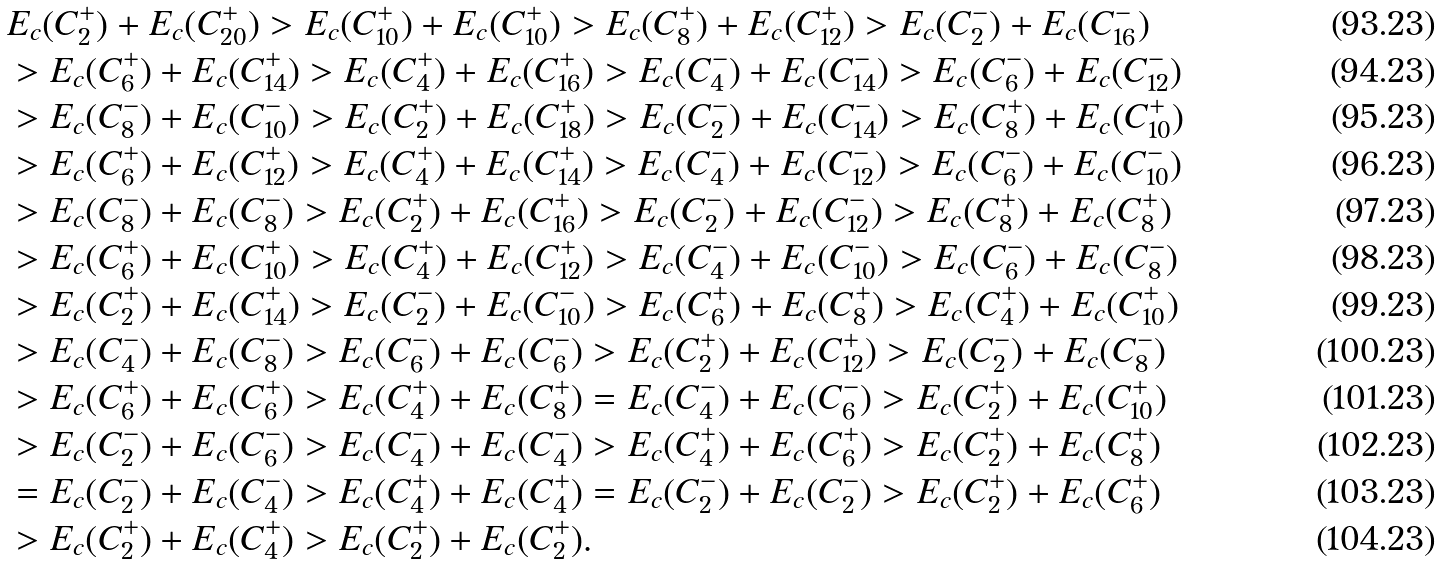Convert formula to latex. <formula><loc_0><loc_0><loc_500><loc_500>& E _ { c } ( C _ { 2 } ^ { + } ) + E _ { c } ( C _ { 2 0 } ^ { + } ) > E _ { c } ( C _ { 1 0 } ^ { + } ) + E _ { c } ( C _ { 1 0 } ^ { + } ) > E _ { c } ( C _ { 8 } ^ { + } ) + E _ { c } ( C _ { 1 2 } ^ { + } ) > E _ { c } ( C _ { 2 } ^ { - } ) + E _ { c } ( C _ { 1 6 } ^ { - } ) \\ & > E _ { c } ( C _ { 6 } ^ { + } ) + E _ { c } ( C _ { 1 4 } ^ { + } ) > E _ { c } ( C _ { 4 } ^ { + } ) + E _ { c } ( C _ { 1 6 } ^ { + } ) > E _ { c } ( C _ { 4 } ^ { - } ) + E _ { c } ( C _ { 1 4 } ^ { - } ) > E _ { c } ( C _ { 6 } ^ { - } ) + E _ { c } ( C _ { 1 2 } ^ { - } ) \\ & > E _ { c } ( C _ { 8 } ^ { - } ) + E _ { c } ( C _ { 1 0 } ^ { - } ) > E _ { c } ( C _ { 2 } ^ { + } ) + E _ { c } ( C _ { 1 8 } ^ { + } ) > E _ { c } ( C _ { 2 } ^ { - } ) + E _ { c } ( C _ { 1 4 } ^ { - } ) > E _ { c } ( C _ { 8 } ^ { + } ) + E _ { c } ( C _ { 1 0 } ^ { + } ) \\ & > E _ { c } ( C _ { 6 } ^ { + } ) + E _ { c } ( C _ { 1 2 } ^ { + } ) > E _ { c } ( C _ { 4 } ^ { + } ) + E _ { c } ( C _ { 1 4 } ^ { + } ) > E _ { c } ( C _ { 4 } ^ { - } ) + E _ { c } ( C _ { 1 2 } ^ { - } ) > E _ { c } ( C _ { 6 } ^ { - } ) + E _ { c } ( C _ { 1 0 } ^ { - } ) \\ & > E _ { c } ( C _ { 8 } ^ { - } ) + E _ { c } ( C _ { 8 } ^ { - } ) > E _ { c } ( C _ { 2 } ^ { + } ) + E _ { c } ( C _ { 1 6 } ^ { + } ) > E _ { c } ( C _ { 2 } ^ { - } ) + E _ { c } ( C _ { 1 2 } ^ { - } ) > E _ { c } ( C _ { 8 } ^ { + } ) + E _ { c } ( C _ { 8 } ^ { + } ) \\ & > E _ { c } ( C _ { 6 } ^ { + } ) + E _ { c } ( C _ { 1 0 } ^ { + } ) > E _ { c } ( C _ { 4 } ^ { + } ) + E _ { c } ( C _ { 1 2 } ^ { + } ) > E _ { c } ( C _ { 4 } ^ { - } ) + E _ { c } ( C _ { 1 0 } ^ { - } ) > E _ { c } ( C _ { 6 } ^ { - } ) + E _ { c } ( C _ { 8 } ^ { - } ) \\ & > E _ { c } ( C _ { 2 } ^ { + } ) + E _ { c } ( C _ { 1 4 } ^ { + } ) > E _ { c } ( C _ { 2 } ^ { - } ) + E _ { c } ( C _ { 1 0 } ^ { - } ) > E _ { c } ( C _ { 6 } ^ { + } ) + E _ { c } ( C _ { 8 } ^ { + } ) > E _ { c } ( C _ { 4 } ^ { + } ) + E _ { c } ( C _ { 1 0 } ^ { + } ) \\ & > E _ { c } ( C _ { 4 } ^ { - } ) + E _ { c } ( C _ { 8 } ^ { - } ) > E _ { c } ( C _ { 6 } ^ { - } ) + E _ { c } ( C _ { 6 } ^ { - } ) > E _ { c } ( C _ { 2 } ^ { + } ) + E _ { c } ( C _ { 1 2 } ^ { + } ) > E _ { c } ( C _ { 2 } ^ { - } ) + E _ { c } ( C _ { 8 } ^ { - } ) \\ & > E _ { c } ( C _ { 6 } ^ { + } ) + E _ { c } ( C _ { 6 } ^ { + } ) > E _ { c } ( C _ { 4 } ^ { + } ) + E _ { c } ( C _ { 8 } ^ { + } ) = E _ { c } ( C _ { 4 } ^ { - } ) + E _ { c } ( C _ { 6 } ^ { - } ) > E _ { c } ( C _ { 2 } ^ { + } ) + E _ { c } ( C _ { 1 0 } ^ { + } ) \\ & > E _ { c } ( C _ { 2 } ^ { - } ) + E _ { c } ( C _ { 6 } ^ { - } ) > E _ { c } ( C _ { 4 } ^ { - } ) + E _ { c } ( C _ { 4 } ^ { - } ) > E _ { c } ( C _ { 4 } ^ { + } ) + E _ { c } ( C _ { 6 } ^ { + } ) > E _ { c } ( C _ { 2 } ^ { + } ) + E _ { c } ( C _ { 8 } ^ { + } ) \\ & = E _ { c } ( C _ { 2 } ^ { - } ) + E _ { c } ( C _ { 4 } ^ { - } ) > E _ { c } ( C _ { 4 } ^ { + } ) + E _ { c } ( C _ { 4 } ^ { + } ) = E _ { c } ( C _ { 2 } ^ { - } ) + E _ { c } ( C _ { 2 } ^ { - } ) > E _ { c } ( C _ { 2 } ^ { + } ) + E _ { c } ( C _ { 6 } ^ { + } ) \\ & > E _ { c } ( C _ { 2 } ^ { + } ) + E _ { c } ( C _ { 4 } ^ { + } ) > E _ { c } ( C _ { 2 } ^ { + } ) + E _ { c } ( C _ { 2 } ^ { + } ) .</formula> 